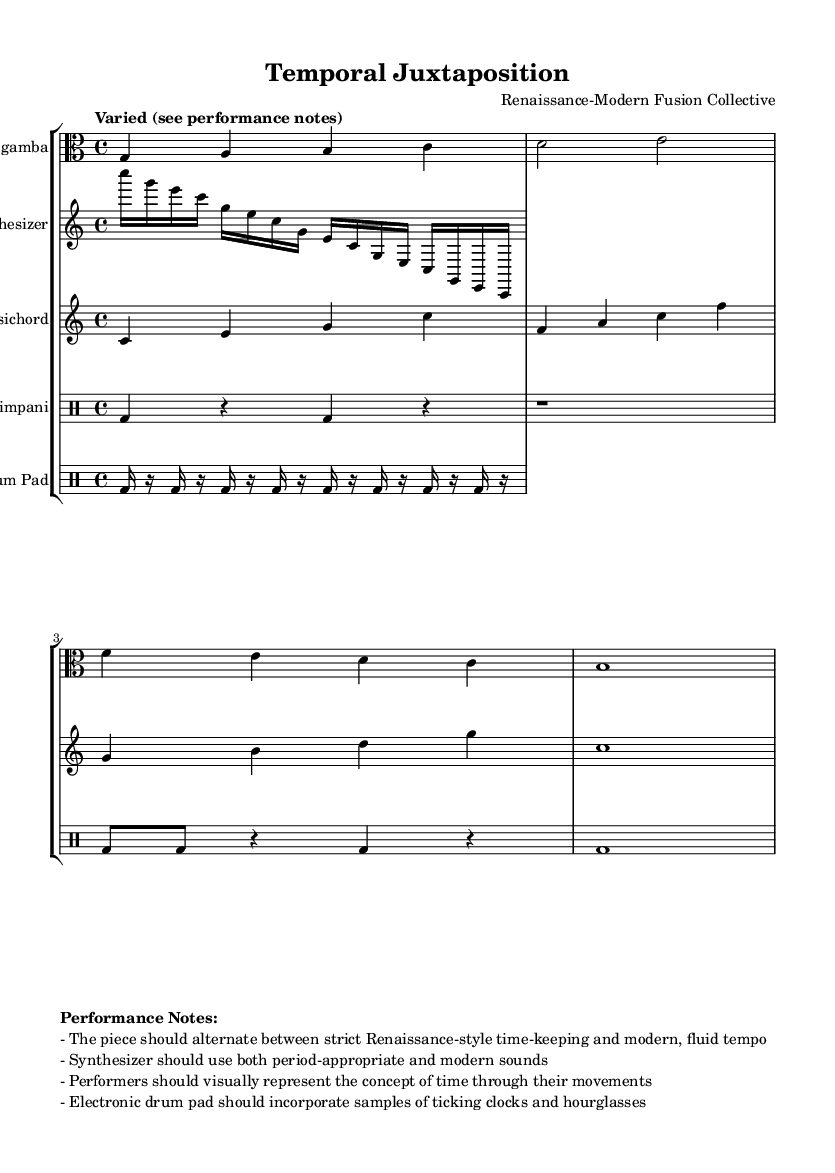What is the time signature of this music? The time signature is indicated at the beginning of the score as 4/4, which means there are four beats in a measure and a quarter note receives one beat.
Answer: 4/4 What instruments are featured in this composition? The instruments are listed under the staff groups at the beginning of the score. They are Viola da gamba, Synthesizer, Harpsichord, Timpani, and Electronic Drum Pad.
Answer: Viola da gamba, Synthesizer, Harpsichord, Timpani, Electronic Drum Pad How many measures are present in the Viola da gamba part? To determine the number of measures, count the vertical lines that divide the measures in the viola part. There are four measures in total.
Answer: 4 What is the tempo indication in the score? The tempo is described as "Varied (see performance notes)" in the header. It suggests that the speed of the piece will change according to the performance notes provided.
Answer: Varied Which instrument incorporates samples of ticking clocks? The performance notes specify that the Electronic Drum Pad should incorporate samples of ticking clocks and hourglasses, highlighting its experimental nature.
Answer: Electronic Drum Pad What type of sounds should the synthesizer use? The performance notes instruct that the synthesizer should use both period-appropriate and modern sounds, blending elements from both the Renaissance and contemporary contexts.
Answer: Period-appropriate and modern sounds How should performers represent the concept of time during the performance? The performance notes state that performers should visually represent the concept of time through their movements, indicating a physical expression of the theme in the music.
Answer: Through their movements 